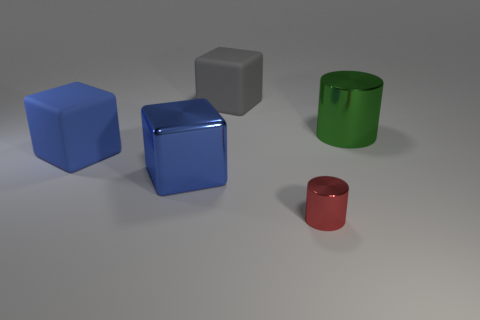Can you tell me the purpose of these objects? The objects in the image seem to be simple geometric shapes commonly used for educational purposes, like teaching about geometry, colors, and spatial relationships. They could also be elements in a graphical rendering or design context, used to demonstrate shading and reflections. 